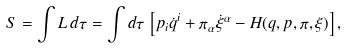Convert formula to latex. <formula><loc_0><loc_0><loc_500><loc_500>S = \int L \, d \tau = \int d \tau \, \left [ p _ { i } \dot { q } ^ { i } + \pi _ { \alpha } \dot { \xi } ^ { \alpha } - H ( q , p , \pi , \xi ) \right ] ,</formula> 